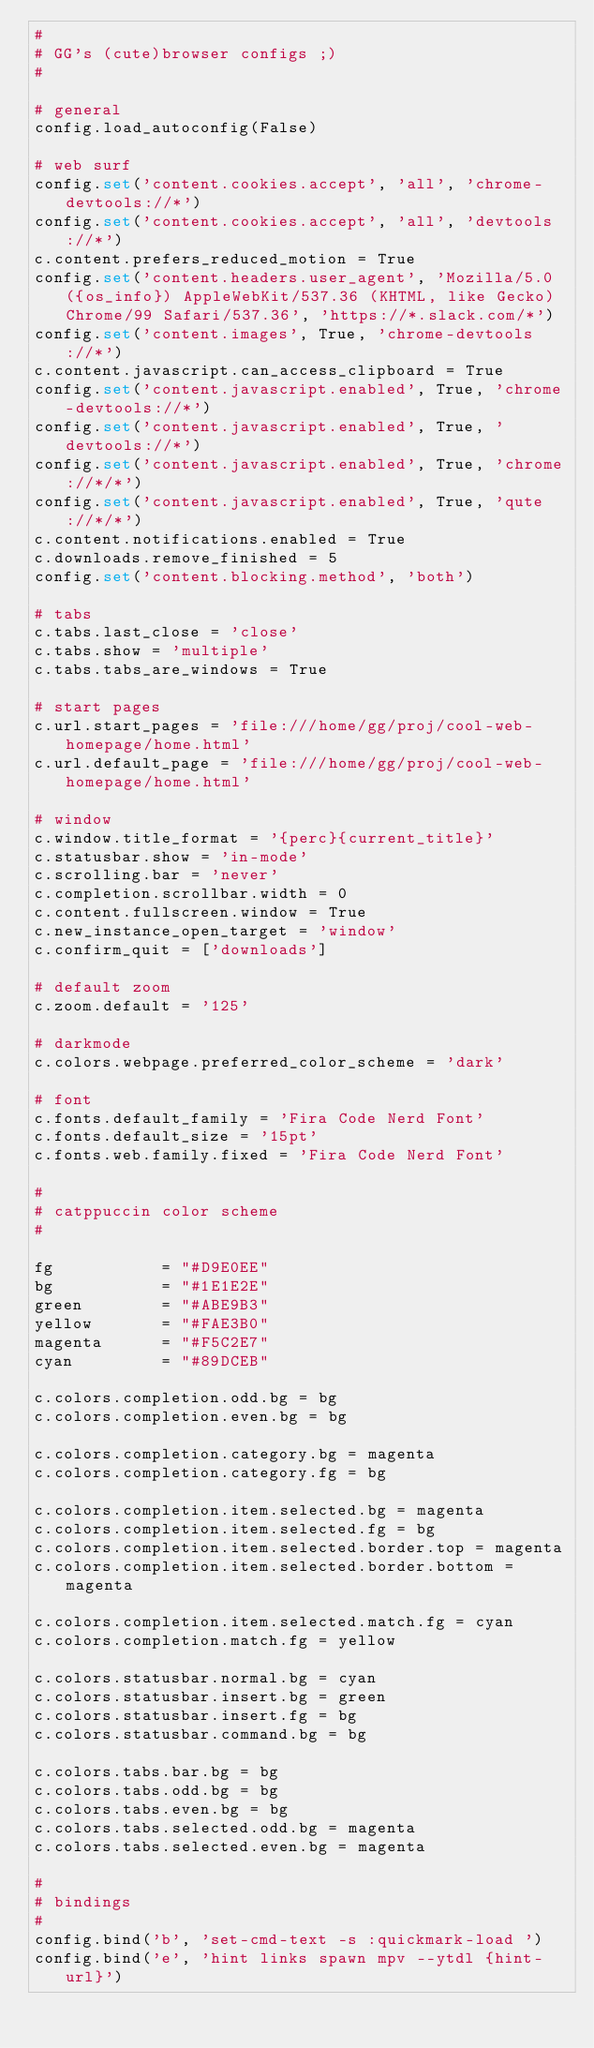Convert code to text. <code><loc_0><loc_0><loc_500><loc_500><_Python_>#
# GG's (cute)browser configs ;)
#

# general
config.load_autoconfig(False)

# web surf
config.set('content.cookies.accept', 'all', 'chrome-devtools://*')
config.set('content.cookies.accept', 'all', 'devtools://*')
c.content.prefers_reduced_motion = True
config.set('content.headers.user_agent', 'Mozilla/5.0 ({os_info}) AppleWebKit/537.36 (KHTML, like Gecko) Chrome/99 Safari/537.36', 'https://*.slack.com/*')
config.set('content.images', True, 'chrome-devtools://*')
c.content.javascript.can_access_clipboard = True
config.set('content.javascript.enabled', True, 'chrome-devtools://*')
config.set('content.javascript.enabled', True, 'devtools://*')
config.set('content.javascript.enabled', True, 'chrome://*/*')
config.set('content.javascript.enabled', True, 'qute://*/*')
c.content.notifications.enabled = True
c.downloads.remove_finished = 5
config.set('content.blocking.method', 'both')

# tabs
c.tabs.last_close = 'close'
c.tabs.show = 'multiple'
c.tabs.tabs_are_windows = True

# start pages
c.url.start_pages = 'file:///home/gg/proj/cool-web-homepage/home.html'
c.url.default_page = 'file:///home/gg/proj/cool-web-homepage/home.html'

# window
c.window.title_format = '{perc}{current_title}'
c.statusbar.show = 'in-mode'
c.scrolling.bar = 'never'
c.completion.scrollbar.width = 0
c.content.fullscreen.window = True
c.new_instance_open_target = 'window'
c.confirm_quit = ['downloads']

# default zoom
c.zoom.default = '125'

# darkmode
c.colors.webpage.preferred_color_scheme = 'dark'

# font
c.fonts.default_family = 'Fira Code Nerd Font'
c.fonts.default_size = '15pt'
c.fonts.web.family.fixed = 'Fira Code Nerd Font'

# 
# catppuccin color scheme
#

fg           = "#D9E0EE"
bg           = "#1E1E2E"
green        = "#ABE9B3"
yellow       = "#FAE3B0"
magenta      = "#F5C2E7"
cyan         = "#89DCEB"

c.colors.completion.odd.bg = bg 
c.colors.completion.even.bg = bg 

c.colors.completion.category.bg = magenta
c.colors.completion.category.fg = bg

c.colors.completion.item.selected.bg = magenta 
c.colors.completion.item.selected.fg = bg 
c.colors.completion.item.selected.border.top = magenta 
c.colors.completion.item.selected.border.bottom = magenta 

c.colors.completion.item.selected.match.fg = cyan 
c.colors.completion.match.fg = yellow 

c.colors.statusbar.normal.bg = cyan 
c.colors.statusbar.insert.bg = green 
c.colors.statusbar.insert.fg = bg 
c.colors.statusbar.command.bg = bg 

c.colors.tabs.bar.bg = bg 
c.colors.tabs.odd.bg = bg 
c.colors.tabs.even.bg = bg 
c.colors.tabs.selected.odd.bg = magenta 
c.colors.tabs.selected.even.bg = magenta 

#
# bindings
#
config.bind('b', 'set-cmd-text -s :quickmark-load ')
config.bind('e', 'hint links spawn mpv --ytdl {hint-url}')
</code> 